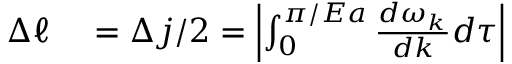<formula> <loc_0><loc_0><loc_500><loc_500>\begin{array} { r l } { \Delta \ell } & = \Delta j / 2 = \left | \int _ { 0 } ^ { \pi / E a } \frac { d \omega _ { k } } { d k } d \tau \right | } \end{array}</formula> 